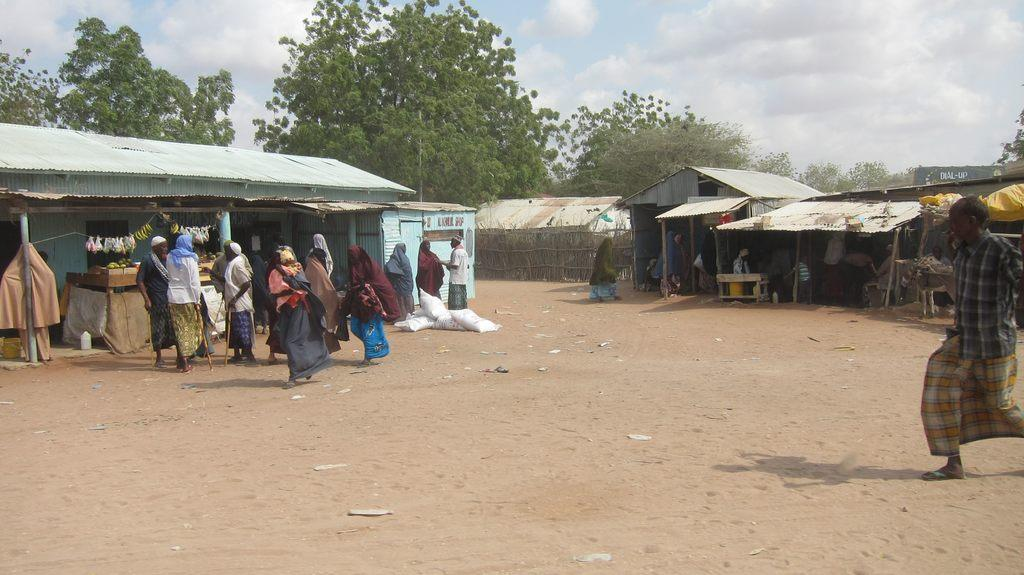What type of surface is visible in the image? There is ground visible in the image. What are the persons in the image doing? The persons are standing on the ground. What color are the bags in the image? The bags in the image are white-colored. What type of structures can be seen in the image? There are sheds in the image. What can be seen in the background of the image? There are trees and the sky visible in the background. Can you tell me how many teeth are visible in the image? There are no teeth visible in the image. What type of lake can be seen in the background of the image? There is no lake present in the image; it features trees and the sky in the background. 